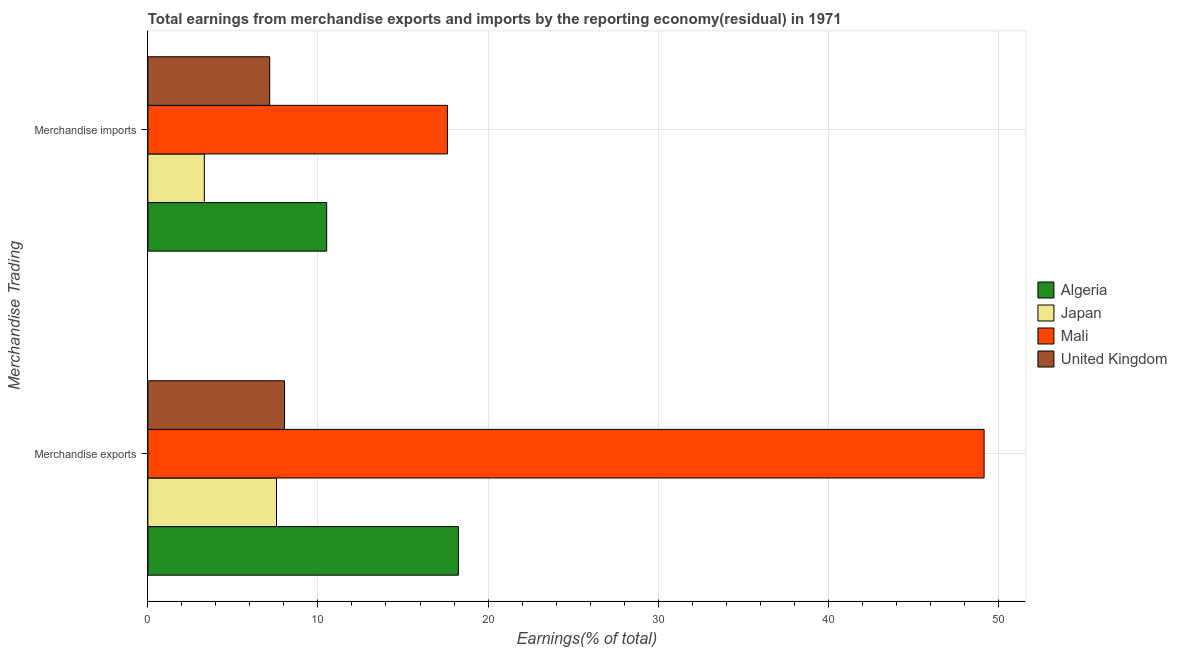How many groups of bars are there?
Offer a terse response. 2. Are the number of bars per tick equal to the number of legend labels?
Ensure brevity in your answer.  Yes. What is the label of the 1st group of bars from the top?
Make the answer very short. Merchandise imports. What is the earnings from merchandise exports in Mali?
Ensure brevity in your answer.  49.17. Across all countries, what is the maximum earnings from merchandise imports?
Your answer should be very brief. 17.61. Across all countries, what is the minimum earnings from merchandise imports?
Your answer should be compact. 3.32. In which country was the earnings from merchandise imports maximum?
Your response must be concise. Mali. What is the total earnings from merchandise exports in the graph?
Make the answer very short. 83.02. What is the difference between the earnings from merchandise exports in Algeria and that in United Kingdom?
Keep it short and to the point. 10.22. What is the difference between the earnings from merchandise imports in Japan and the earnings from merchandise exports in United Kingdom?
Your response must be concise. -4.72. What is the average earnings from merchandise exports per country?
Your answer should be very brief. 20.76. What is the difference between the earnings from merchandise exports and earnings from merchandise imports in Algeria?
Make the answer very short. 7.74. In how many countries, is the earnings from merchandise exports greater than 2 %?
Provide a short and direct response. 4. What is the ratio of the earnings from merchandise exports in Algeria to that in United Kingdom?
Your answer should be very brief. 2.27. In how many countries, is the earnings from merchandise exports greater than the average earnings from merchandise exports taken over all countries?
Make the answer very short. 1. What does the 4th bar from the top in Merchandise exports represents?
Your answer should be compact. Algeria. How many bars are there?
Provide a short and direct response. 8. What is the difference between two consecutive major ticks on the X-axis?
Your answer should be very brief. 10. Are the values on the major ticks of X-axis written in scientific E-notation?
Your answer should be very brief. No. Does the graph contain any zero values?
Offer a terse response. No. Where does the legend appear in the graph?
Your response must be concise. Center right. How many legend labels are there?
Offer a terse response. 4. How are the legend labels stacked?
Ensure brevity in your answer.  Vertical. What is the title of the graph?
Give a very brief answer. Total earnings from merchandise exports and imports by the reporting economy(residual) in 1971. Does "Vietnam" appear as one of the legend labels in the graph?
Give a very brief answer. No. What is the label or title of the X-axis?
Provide a short and direct response. Earnings(% of total). What is the label or title of the Y-axis?
Your answer should be compact. Merchandise Trading. What is the Earnings(% of total) of Algeria in Merchandise exports?
Make the answer very short. 18.26. What is the Earnings(% of total) in Japan in Merchandise exports?
Keep it short and to the point. 7.56. What is the Earnings(% of total) in Mali in Merchandise exports?
Offer a terse response. 49.17. What is the Earnings(% of total) of United Kingdom in Merchandise exports?
Ensure brevity in your answer.  8.04. What is the Earnings(% of total) of Algeria in Merchandise imports?
Your response must be concise. 10.51. What is the Earnings(% of total) in Japan in Merchandise imports?
Make the answer very short. 3.32. What is the Earnings(% of total) of Mali in Merchandise imports?
Keep it short and to the point. 17.61. What is the Earnings(% of total) of United Kingdom in Merchandise imports?
Provide a short and direct response. 7.16. Across all Merchandise Trading, what is the maximum Earnings(% of total) of Algeria?
Give a very brief answer. 18.26. Across all Merchandise Trading, what is the maximum Earnings(% of total) of Japan?
Make the answer very short. 7.56. Across all Merchandise Trading, what is the maximum Earnings(% of total) in Mali?
Your answer should be very brief. 49.17. Across all Merchandise Trading, what is the maximum Earnings(% of total) in United Kingdom?
Provide a succinct answer. 8.04. Across all Merchandise Trading, what is the minimum Earnings(% of total) of Algeria?
Make the answer very short. 10.51. Across all Merchandise Trading, what is the minimum Earnings(% of total) in Japan?
Provide a short and direct response. 3.32. Across all Merchandise Trading, what is the minimum Earnings(% of total) in Mali?
Give a very brief answer. 17.61. Across all Merchandise Trading, what is the minimum Earnings(% of total) of United Kingdom?
Provide a short and direct response. 7.16. What is the total Earnings(% of total) of Algeria in the graph?
Make the answer very short. 28.77. What is the total Earnings(% of total) in Japan in the graph?
Your answer should be very brief. 10.88. What is the total Earnings(% of total) in Mali in the graph?
Offer a very short reply. 66.78. What is the total Earnings(% of total) of United Kingdom in the graph?
Offer a very short reply. 15.2. What is the difference between the Earnings(% of total) of Algeria in Merchandise exports and that in Merchandise imports?
Provide a short and direct response. 7.74. What is the difference between the Earnings(% of total) in Japan in Merchandise exports and that in Merchandise imports?
Keep it short and to the point. 4.24. What is the difference between the Earnings(% of total) of Mali in Merchandise exports and that in Merchandise imports?
Offer a very short reply. 31.55. What is the difference between the Earnings(% of total) in United Kingdom in Merchandise exports and that in Merchandise imports?
Give a very brief answer. 0.88. What is the difference between the Earnings(% of total) in Algeria in Merchandise exports and the Earnings(% of total) in Japan in Merchandise imports?
Make the answer very short. 14.94. What is the difference between the Earnings(% of total) in Algeria in Merchandise exports and the Earnings(% of total) in Mali in Merchandise imports?
Give a very brief answer. 0.64. What is the difference between the Earnings(% of total) in Algeria in Merchandise exports and the Earnings(% of total) in United Kingdom in Merchandise imports?
Your answer should be very brief. 11.1. What is the difference between the Earnings(% of total) in Japan in Merchandise exports and the Earnings(% of total) in Mali in Merchandise imports?
Your answer should be compact. -10.05. What is the difference between the Earnings(% of total) of Japan in Merchandise exports and the Earnings(% of total) of United Kingdom in Merchandise imports?
Your answer should be compact. 0.4. What is the difference between the Earnings(% of total) of Mali in Merchandise exports and the Earnings(% of total) of United Kingdom in Merchandise imports?
Provide a succinct answer. 42. What is the average Earnings(% of total) of Algeria per Merchandise Trading?
Offer a terse response. 14.38. What is the average Earnings(% of total) in Japan per Merchandise Trading?
Provide a succinct answer. 5.44. What is the average Earnings(% of total) in Mali per Merchandise Trading?
Keep it short and to the point. 33.39. What is the average Earnings(% of total) in United Kingdom per Merchandise Trading?
Your answer should be very brief. 7.6. What is the difference between the Earnings(% of total) in Algeria and Earnings(% of total) in Japan in Merchandise exports?
Keep it short and to the point. 10.69. What is the difference between the Earnings(% of total) in Algeria and Earnings(% of total) in Mali in Merchandise exports?
Ensure brevity in your answer.  -30.91. What is the difference between the Earnings(% of total) in Algeria and Earnings(% of total) in United Kingdom in Merchandise exports?
Ensure brevity in your answer.  10.22. What is the difference between the Earnings(% of total) in Japan and Earnings(% of total) in Mali in Merchandise exports?
Provide a short and direct response. -41.6. What is the difference between the Earnings(% of total) in Japan and Earnings(% of total) in United Kingdom in Merchandise exports?
Provide a short and direct response. -0.47. What is the difference between the Earnings(% of total) in Mali and Earnings(% of total) in United Kingdom in Merchandise exports?
Ensure brevity in your answer.  41.13. What is the difference between the Earnings(% of total) in Algeria and Earnings(% of total) in Japan in Merchandise imports?
Make the answer very short. 7.19. What is the difference between the Earnings(% of total) in Algeria and Earnings(% of total) in Mali in Merchandise imports?
Provide a short and direct response. -7.1. What is the difference between the Earnings(% of total) in Algeria and Earnings(% of total) in United Kingdom in Merchandise imports?
Your answer should be very brief. 3.35. What is the difference between the Earnings(% of total) in Japan and Earnings(% of total) in Mali in Merchandise imports?
Provide a short and direct response. -14.29. What is the difference between the Earnings(% of total) of Japan and Earnings(% of total) of United Kingdom in Merchandise imports?
Offer a terse response. -3.84. What is the difference between the Earnings(% of total) of Mali and Earnings(% of total) of United Kingdom in Merchandise imports?
Ensure brevity in your answer.  10.45. What is the ratio of the Earnings(% of total) in Algeria in Merchandise exports to that in Merchandise imports?
Ensure brevity in your answer.  1.74. What is the ratio of the Earnings(% of total) in Japan in Merchandise exports to that in Merchandise imports?
Make the answer very short. 2.28. What is the ratio of the Earnings(% of total) of Mali in Merchandise exports to that in Merchandise imports?
Your answer should be compact. 2.79. What is the ratio of the Earnings(% of total) in United Kingdom in Merchandise exports to that in Merchandise imports?
Your answer should be very brief. 1.12. What is the difference between the highest and the second highest Earnings(% of total) in Algeria?
Provide a succinct answer. 7.74. What is the difference between the highest and the second highest Earnings(% of total) in Japan?
Keep it short and to the point. 4.24. What is the difference between the highest and the second highest Earnings(% of total) of Mali?
Your response must be concise. 31.55. What is the difference between the highest and the second highest Earnings(% of total) in United Kingdom?
Offer a very short reply. 0.88. What is the difference between the highest and the lowest Earnings(% of total) in Algeria?
Keep it short and to the point. 7.74. What is the difference between the highest and the lowest Earnings(% of total) of Japan?
Offer a terse response. 4.24. What is the difference between the highest and the lowest Earnings(% of total) of Mali?
Ensure brevity in your answer.  31.55. What is the difference between the highest and the lowest Earnings(% of total) of United Kingdom?
Your answer should be very brief. 0.88. 